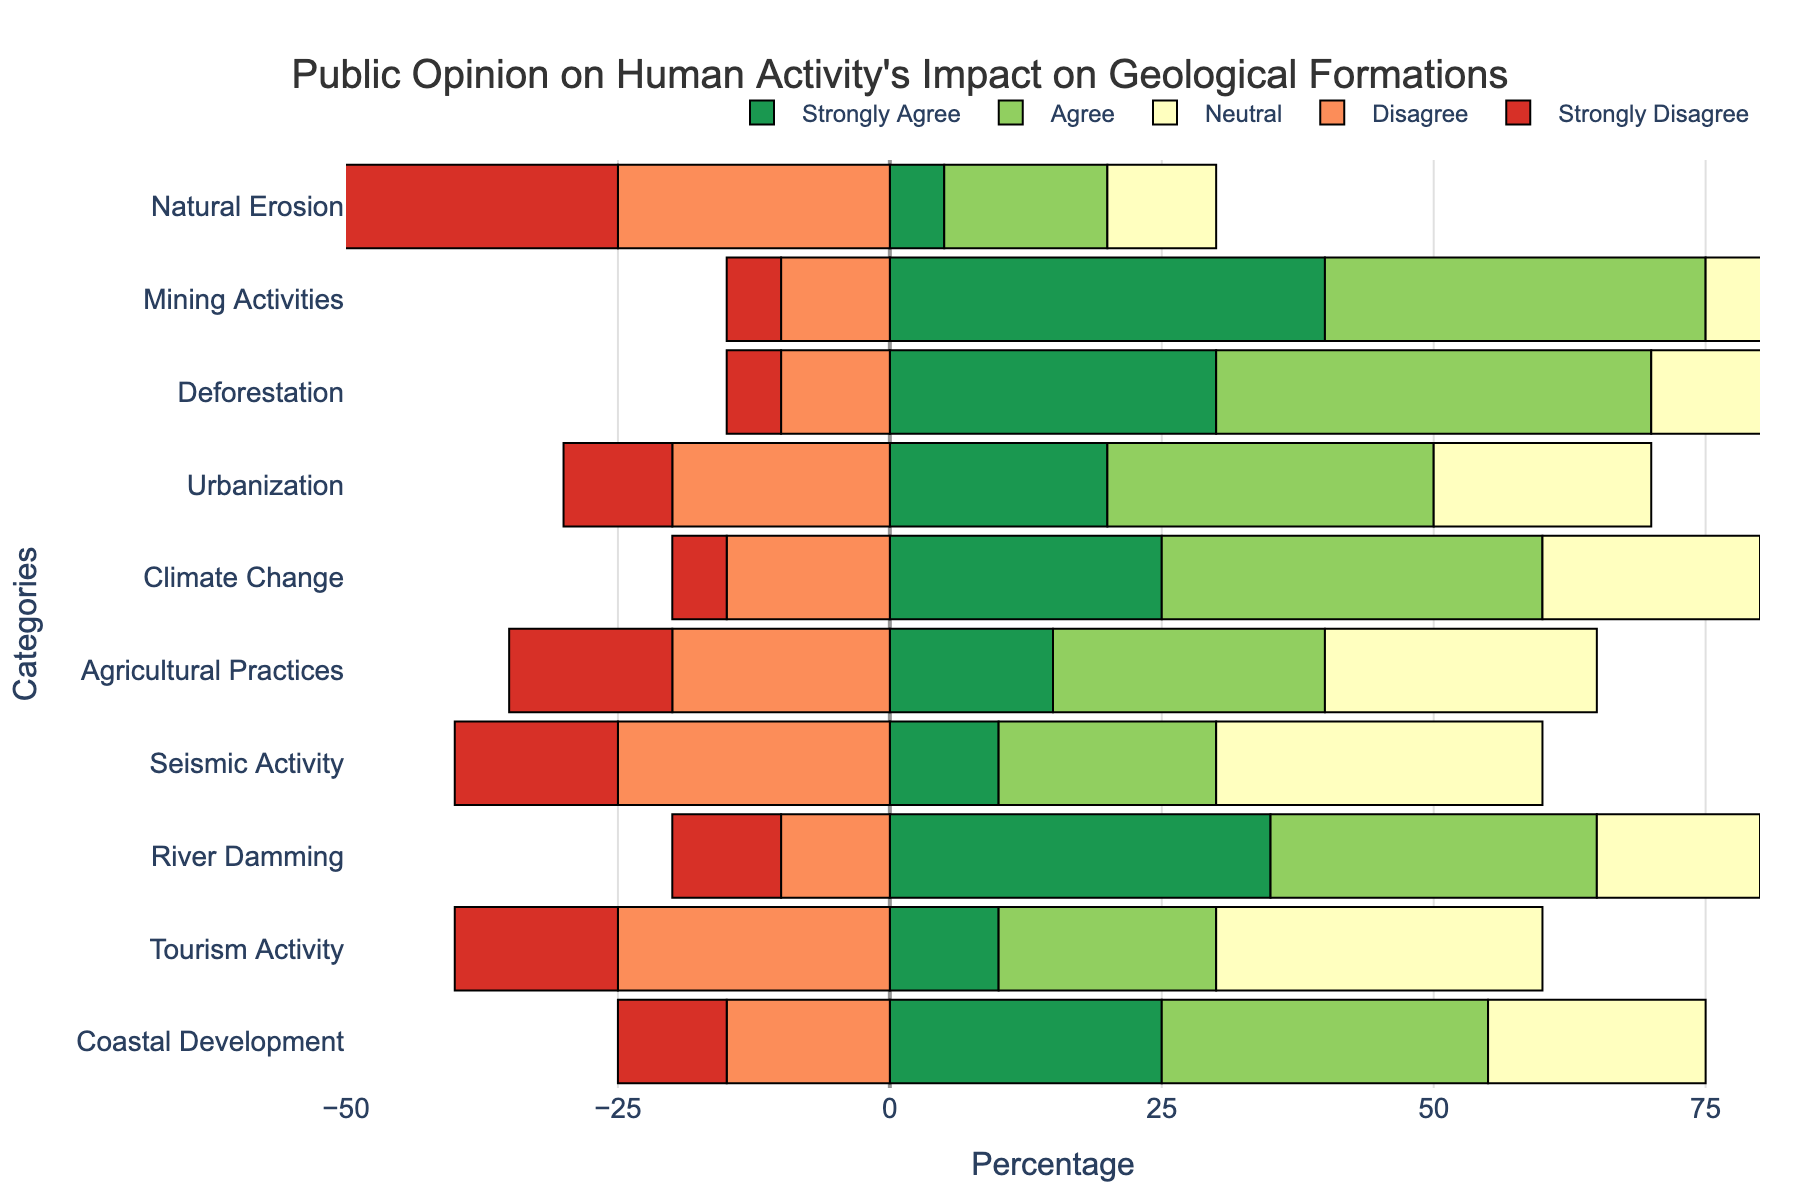What category has the highest percentage of 'Strongly Agree'? By looking at the green bars, observe which category has the longest green bar. Mining Activities has the longest green bar at 40%.
Answer: Mining Activities Which category has the most disagreement ('Disagree' + 'Strongly Disagree')? Sum the lengths of the red and orange bars for each category. Natural Erosion has 25% + 45% = 70%, which is the highest among all categories.
Answer: Natural Erosion How does public opinion on 'Deforestation' compare to 'Agricultural Practices' in terms of neutrality ('Neutral')? Compare the yellow bars for 'Deforestation' and 'Agricultural Practices'. 'Deforestation' has 15% 'Neutral', while 'Agricultural Practices' has 25% 'Neutral'.
Answer: Agricultural Practices has higher neutrality Which has more 'Agree' statements: 'Urbanization' or 'Coastal Development'? Compare the light green bars for 'Agree'. 'Urbanization' has 30%, while 'Coastal Development' also has 30%.
Answer: They are equal What is the total percentage of agreement ('Strongly Agree' + 'Agree') for 'Climate Change'? Add the lengths of the green and light green bars for 'Climate Change': 25% + 35% = 60%.
Answer: 60% For which category is the percentage of 'Neutral' opinion the highest? Look for the longest yellow bar. Seismic Activity and Tourism Activity both have the highest at 30%.
Answer: Seismic Activity and Tourism Activity Which two categories have the largest difference in 'Strongly Disagree' percentages? Find the length of the red bars for all categories and identify the maximum and minimum values. The largest is Natural Erosion (45%) and the smallest is Mining Activities (5%), difference is 40%.
Answer: Natural Erosion and Mining Activities What is the average percentage of 'Disagree' across all categories? Sum the 'Disagree' percentages and divide by the number of categories: (25 + 10 + 10 + 20 + 15 + 20 + 25 + 10 + 25 + 15) / 10 = 195 / 10 = 19.5%.
Answer: 19.5% Which category has the least 'Strongly Agree' percentages? Find the shortest green bar. Natural Erosion has the smallest at 5%.
Answer: Natural Erosion Is 'Mining Activities' viewed more favorably (combining 'Strongly Agree' and 'Agree') compared to 'River Damming'? Compare the sum of green and light green bars for both categories: Mining Activities (40 + 35 = 75%), River Damming (35 + 30 = 65%). Thus, 75% is greater than 65%.
Answer: Yes 